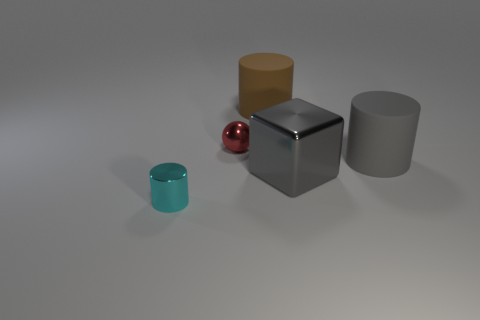Add 1 small cyan cylinders. How many objects exist? 6 Subtract all spheres. How many objects are left? 4 Add 2 large cylinders. How many large cylinders exist? 4 Subtract 1 gray cylinders. How many objects are left? 4 Subtract all large things. Subtract all small matte spheres. How many objects are left? 2 Add 5 large matte cylinders. How many large matte cylinders are left? 7 